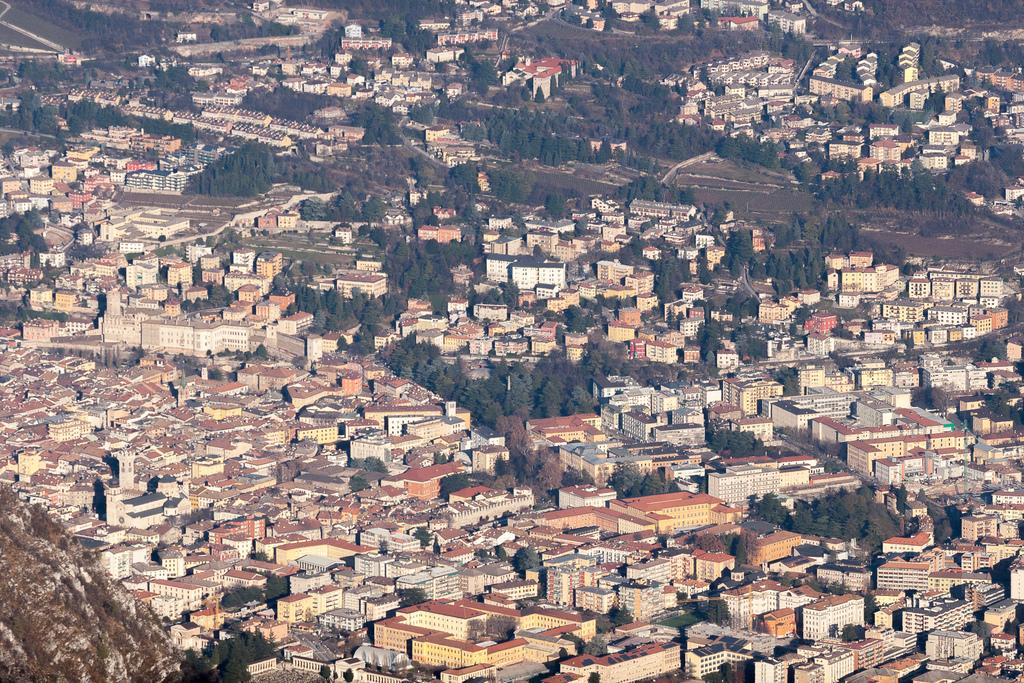What type of view is provided in the image? The image is an aerial view. What structures can be seen from this perspective? There are buildings visible in the image. What natural elements are present in the image? There are trees visible in the image. What is the primary surface visible in the image? The ground is visible in the image. How many sticks are used for addition in the image? There are no sticks or addition calculations present in the image. 